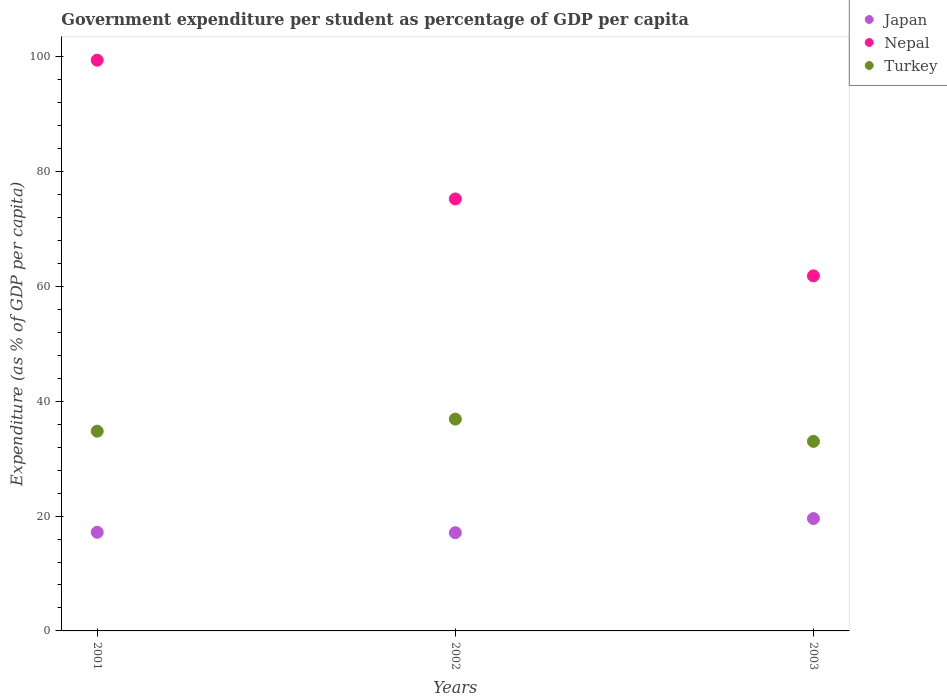Is the number of dotlines equal to the number of legend labels?
Make the answer very short. Yes. What is the percentage of expenditure per student in Turkey in 2001?
Give a very brief answer. 34.78. Across all years, what is the maximum percentage of expenditure per student in Nepal?
Give a very brief answer. 99.39. Across all years, what is the minimum percentage of expenditure per student in Nepal?
Make the answer very short. 61.83. What is the total percentage of expenditure per student in Nepal in the graph?
Offer a very short reply. 236.46. What is the difference between the percentage of expenditure per student in Nepal in 2001 and that in 2002?
Give a very brief answer. 24.16. What is the difference between the percentage of expenditure per student in Turkey in 2002 and the percentage of expenditure per student in Japan in 2001?
Provide a short and direct response. 19.71. What is the average percentage of expenditure per student in Turkey per year?
Your answer should be compact. 34.89. In the year 2002, what is the difference between the percentage of expenditure per student in Japan and percentage of expenditure per student in Nepal?
Keep it short and to the point. -58.13. In how many years, is the percentage of expenditure per student in Nepal greater than 36 %?
Your answer should be compact. 3. What is the ratio of the percentage of expenditure per student in Turkey in 2001 to that in 2002?
Provide a short and direct response. 0.94. What is the difference between the highest and the second highest percentage of expenditure per student in Japan?
Your answer should be very brief. 2.39. What is the difference between the highest and the lowest percentage of expenditure per student in Turkey?
Offer a terse response. 3.88. In how many years, is the percentage of expenditure per student in Japan greater than the average percentage of expenditure per student in Japan taken over all years?
Make the answer very short. 1. Is it the case that in every year, the sum of the percentage of expenditure per student in Japan and percentage of expenditure per student in Nepal  is greater than the percentage of expenditure per student in Turkey?
Your response must be concise. Yes. Is the percentage of expenditure per student in Nepal strictly greater than the percentage of expenditure per student in Japan over the years?
Your answer should be compact. Yes. Is the percentage of expenditure per student in Nepal strictly less than the percentage of expenditure per student in Turkey over the years?
Give a very brief answer. No. What is the difference between two consecutive major ticks on the Y-axis?
Make the answer very short. 20. Does the graph contain any zero values?
Offer a very short reply. No. How are the legend labels stacked?
Provide a succinct answer. Vertical. What is the title of the graph?
Keep it short and to the point. Government expenditure per student as percentage of GDP per capita. Does "Faeroe Islands" appear as one of the legend labels in the graph?
Your answer should be compact. No. What is the label or title of the Y-axis?
Provide a short and direct response. Expenditure (as % of GDP per capita). What is the Expenditure (as % of GDP per capita) of Japan in 2001?
Make the answer very short. 17.18. What is the Expenditure (as % of GDP per capita) in Nepal in 2001?
Offer a terse response. 99.39. What is the Expenditure (as % of GDP per capita) of Turkey in 2001?
Give a very brief answer. 34.78. What is the Expenditure (as % of GDP per capita) of Japan in 2002?
Keep it short and to the point. 17.1. What is the Expenditure (as % of GDP per capita) in Nepal in 2002?
Offer a terse response. 75.23. What is the Expenditure (as % of GDP per capita) in Turkey in 2002?
Your answer should be compact. 36.89. What is the Expenditure (as % of GDP per capita) in Japan in 2003?
Provide a succinct answer. 19.57. What is the Expenditure (as % of GDP per capita) of Nepal in 2003?
Make the answer very short. 61.83. What is the Expenditure (as % of GDP per capita) in Turkey in 2003?
Your answer should be compact. 33.01. Across all years, what is the maximum Expenditure (as % of GDP per capita) of Japan?
Keep it short and to the point. 19.57. Across all years, what is the maximum Expenditure (as % of GDP per capita) in Nepal?
Make the answer very short. 99.39. Across all years, what is the maximum Expenditure (as % of GDP per capita) in Turkey?
Keep it short and to the point. 36.89. Across all years, what is the minimum Expenditure (as % of GDP per capita) of Japan?
Your response must be concise. 17.1. Across all years, what is the minimum Expenditure (as % of GDP per capita) in Nepal?
Your answer should be compact. 61.83. Across all years, what is the minimum Expenditure (as % of GDP per capita) in Turkey?
Provide a succinct answer. 33.01. What is the total Expenditure (as % of GDP per capita) in Japan in the graph?
Offer a very short reply. 53.85. What is the total Expenditure (as % of GDP per capita) in Nepal in the graph?
Make the answer very short. 236.46. What is the total Expenditure (as % of GDP per capita) in Turkey in the graph?
Offer a very short reply. 104.68. What is the difference between the Expenditure (as % of GDP per capita) of Japan in 2001 and that in 2002?
Provide a succinct answer. 0.07. What is the difference between the Expenditure (as % of GDP per capita) of Nepal in 2001 and that in 2002?
Provide a succinct answer. 24.16. What is the difference between the Expenditure (as % of GDP per capita) in Turkey in 2001 and that in 2002?
Offer a terse response. -2.1. What is the difference between the Expenditure (as % of GDP per capita) in Japan in 2001 and that in 2003?
Your answer should be very brief. -2.39. What is the difference between the Expenditure (as % of GDP per capita) of Nepal in 2001 and that in 2003?
Your answer should be very brief. 37.56. What is the difference between the Expenditure (as % of GDP per capita) of Turkey in 2001 and that in 2003?
Give a very brief answer. 1.77. What is the difference between the Expenditure (as % of GDP per capita) in Japan in 2002 and that in 2003?
Provide a succinct answer. -2.46. What is the difference between the Expenditure (as % of GDP per capita) of Nepal in 2002 and that in 2003?
Offer a very short reply. 13.4. What is the difference between the Expenditure (as % of GDP per capita) of Turkey in 2002 and that in 2003?
Provide a succinct answer. 3.88. What is the difference between the Expenditure (as % of GDP per capita) in Japan in 2001 and the Expenditure (as % of GDP per capita) in Nepal in 2002?
Your response must be concise. -58.06. What is the difference between the Expenditure (as % of GDP per capita) of Japan in 2001 and the Expenditure (as % of GDP per capita) of Turkey in 2002?
Keep it short and to the point. -19.71. What is the difference between the Expenditure (as % of GDP per capita) in Nepal in 2001 and the Expenditure (as % of GDP per capita) in Turkey in 2002?
Offer a very short reply. 62.5. What is the difference between the Expenditure (as % of GDP per capita) of Japan in 2001 and the Expenditure (as % of GDP per capita) of Nepal in 2003?
Ensure brevity in your answer.  -44.65. What is the difference between the Expenditure (as % of GDP per capita) of Japan in 2001 and the Expenditure (as % of GDP per capita) of Turkey in 2003?
Keep it short and to the point. -15.83. What is the difference between the Expenditure (as % of GDP per capita) of Nepal in 2001 and the Expenditure (as % of GDP per capita) of Turkey in 2003?
Provide a succinct answer. 66.38. What is the difference between the Expenditure (as % of GDP per capita) in Japan in 2002 and the Expenditure (as % of GDP per capita) in Nepal in 2003?
Offer a terse response. -44.73. What is the difference between the Expenditure (as % of GDP per capita) of Japan in 2002 and the Expenditure (as % of GDP per capita) of Turkey in 2003?
Offer a very short reply. -15.9. What is the difference between the Expenditure (as % of GDP per capita) in Nepal in 2002 and the Expenditure (as % of GDP per capita) in Turkey in 2003?
Make the answer very short. 42.22. What is the average Expenditure (as % of GDP per capita) of Japan per year?
Offer a terse response. 17.95. What is the average Expenditure (as % of GDP per capita) in Nepal per year?
Offer a terse response. 78.82. What is the average Expenditure (as % of GDP per capita) of Turkey per year?
Your answer should be compact. 34.89. In the year 2001, what is the difference between the Expenditure (as % of GDP per capita) of Japan and Expenditure (as % of GDP per capita) of Nepal?
Ensure brevity in your answer.  -82.21. In the year 2001, what is the difference between the Expenditure (as % of GDP per capita) in Japan and Expenditure (as % of GDP per capita) in Turkey?
Your answer should be very brief. -17.61. In the year 2001, what is the difference between the Expenditure (as % of GDP per capita) in Nepal and Expenditure (as % of GDP per capita) in Turkey?
Offer a terse response. 64.61. In the year 2002, what is the difference between the Expenditure (as % of GDP per capita) of Japan and Expenditure (as % of GDP per capita) of Nepal?
Your answer should be compact. -58.13. In the year 2002, what is the difference between the Expenditure (as % of GDP per capita) in Japan and Expenditure (as % of GDP per capita) in Turkey?
Your response must be concise. -19.78. In the year 2002, what is the difference between the Expenditure (as % of GDP per capita) of Nepal and Expenditure (as % of GDP per capita) of Turkey?
Provide a succinct answer. 38.35. In the year 2003, what is the difference between the Expenditure (as % of GDP per capita) in Japan and Expenditure (as % of GDP per capita) in Nepal?
Give a very brief answer. -42.26. In the year 2003, what is the difference between the Expenditure (as % of GDP per capita) in Japan and Expenditure (as % of GDP per capita) in Turkey?
Make the answer very short. -13.44. In the year 2003, what is the difference between the Expenditure (as % of GDP per capita) of Nepal and Expenditure (as % of GDP per capita) of Turkey?
Offer a very short reply. 28.82. What is the ratio of the Expenditure (as % of GDP per capita) in Nepal in 2001 to that in 2002?
Offer a terse response. 1.32. What is the ratio of the Expenditure (as % of GDP per capita) in Turkey in 2001 to that in 2002?
Make the answer very short. 0.94. What is the ratio of the Expenditure (as % of GDP per capita) of Japan in 2001 to that in 2003?
Provide a succinct answer. 0.88. What is the ratio of the Expenditure (as % of GDP per capita) of Nepal in 2001 to that in 2003?
Your answer should be compact. 1.61. What is the ratio of the Expenditure (as % of GDP per capita) of Turkey in 2001 to that in 2003?
Ensure brevity in your answer.  1.05. What is the ratio of the Expenditure (as % of GDP per capita) of Japan in 2002 to that in 2003?
Keep it short and to the point. 0.87. What is the ratio of the Expenditure (as % of GDP per capita) in Nepal in 2002 to that in 2003?
Give a very brief answer. 1.22. What is the ratio of the Expenditure (as % of GDP per capita) of Turkey in 2002 to that in 2003?
Keep it short and to the point. 1.12. What is the difference between the highest and the second highest Expenditure (as % of GDP per capita) of Japan?
Provide a short and direct response. 2.39. What is the difference between the highest and the second highest Expenditure (as % of GDP per capita) in Nepal?
Offer a terse response. 24.16. What is the difference between the highest and the second highest Expenditure (as % of GDP per capita) of Turkey?
Your answer should be very brief. 2.1. What is the difference between the highest and the lowest Expenditure (as % of GDP per capita) of Japan?
Your response must be concise. 2.46. What is the difference between the highest and the lowest Expenditure (as % of GDP per capita) in Nepal?
Make the answer very short. 37.56. What is the difference between the highest and the lowest Expenditure (as % of GDP per capita) in Turkey?
Give a very brief answer. 3.88. 